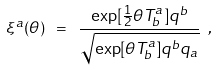Convert formula to latex. <formula><loc_0><loc_0><loc_500><loc_500>\xi ^ { a } ( \theta ) \ = \ \frac { \exp [ \frac { 1 } { 2 } \theta T ^ { a } _ { b } ] q ^ { b } } { \sqrt { \exp [ \theta T ^ { a } _ { b } ] q ^ { b } q _ { a } } } \ ,</formula> 